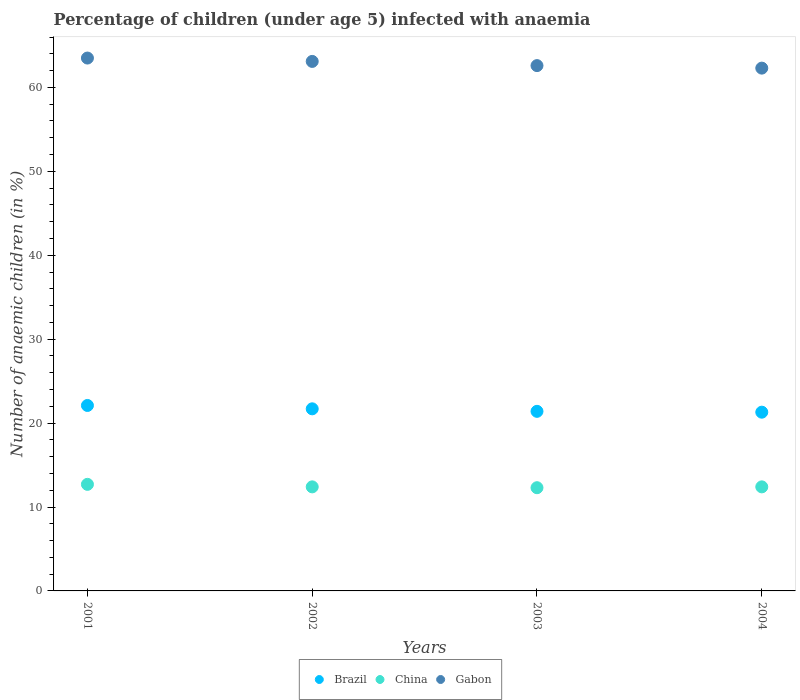How many different coloured dotlines are there?
Provide a short and direct response. 3. Is the number of dotlines equal to the number of legend labels?
Give a very brief answer. Yes. Across all years, what is the maximum percentage of children infected with anaemia in in Gabon?
Offer a terse response. 63.5. Across all years, what is the minimum percentage of children infected with anaemia in in Brazil?
Your answer should be very brief. 21.3. In which year was the percentage of children infected with anaemia in in China maximum?
Ensure brevity in your answer.  2001. In which year was the percentage of children infected with anaemia in in Brazil minimum?
Provide a short and direct response. 2004. What is the total percentage of children infected with anaemia in in Brazil in the graph?
Your answer should be very brief. 86.5. What is the difference between the percentage of children infected with anaemia in in Gabon in 2001 and that in 2004?
Ensure brevity in your answer.  1.2. What is the difference between the percentage of children infected with anaemia in in Brazil in 2004 and the percentage of children infected with anaemia in in China in 2001?
Give a very brief answer. 8.6. What is the average percentage of children infected with anaemia in in China per year?
Your answer should be compact. 12.45. In the year 2004, what is the difference between the percentage of children infected with anaemia in in China and percentage of children infected with anaemia in in Brazil?
Your answer should be very brief. -8.9. In how many years, is the percentage of children infected with anaemia in in China greater than 2 %?
Make the answer very short. 4. What is the ratio of the percentage of children infected with anaemia in in Gabon in 2001 to that in 2002?
Your answer should be compact. 1.01. Is the percentage of children infected with anaemia in in Gabon in 2002 less than that in 2004?
Ensure brevity in your answer.  No. Is the difference between the percentage of children infected with anaemia in in China in 2001 and 2002 greater than the difference between the percentage of children infected with anaemia in in Brazil in 2001 and 2002?
Your answer should be very brief. No. What is the difference between the highest and the second highest percentage of children infected with anaemia in in Gabon?
Ensure brevity in your answer.  0.4. What is the difference between the highest and the lowest percentage of children infected with anaemia in in Gabon?
Offer a terse response. 1.2. In how many years, is the percentage of children infected with anaemia in in China greater than the average percentage of children infected with anaemia in in China taken over all years?
Ensure brevity in your answer.  1. How many dotlines are there?
Make the answer very short. 3. How many legend labels are there?
Provide a short and direct response. 3. What is the title of the graph?
Ensure brevity in your answer.  Percentage of children (under age 5) infected with anaemia. Does "Dominica" appear as one of the legend labels in the graph?
Your answer should be very brief. No. What is the label or title of the X-axis?
Make the answer very short. Years. What is the label or title of the Y-axis?
Ensure brevity in your answer.  Number of anaemic children (in %). What is the Number of anaemic children (in %) of Brazil in 2001?
Ensure brevity in your answer.  22.1. What is the Number of anaemic children (in %) of Gabon in 2001?
Offer a very short reply. 63.5. What is the Number of anaemic children (in %) in Brazil in 2002?
Your response must be concise. 21.7. What is the Number of anaemic children (in %) in Gabon in 2002?
Your response must be concise. 63.1. What is the Number of anaemic children (in %) of Brazil in 2003?
Offer a very short reply. 21.4. What is the Number of anaemic children (in %) of Gabon in 2003?
Your response must be concise. 62.6. What is the Number of anaemic children (in %) of Brazil in 2004?
Your answer should be compact. 21.3. What is the Number of anaemic children (in %) of Gabon in 2004?
Offer a very short reply. 62.3. Across all years, what is the maximum Number of anaemic children (in %) in Brazil?
Give a very brief answer. 22.1. Across all years, what is the maximum Number of anaemic children (in %) of China?
Provide a short and direct response. 12.7. Across all years, what is the maximum Number of anaemic children (in %) in Gabon?
Offer a terse response. 63.5. Across all years, what is the minimum Number of anaemic children (in %) in Brazil?
Ensure brevity in your answer.  21.3. Across all years, what is the minimum Number of anaemic children (in %) in Gabon?
Keep it short and to the point. 62.3. What is the total Number of anaemic children (in %) of Brazil in the graph?
Make the answer very short. 86.5. What is the total Number of anaemic children (in %) in China in the graph?
Provide a succinct answer. 49.8. What is the total Number of anaemic children (in %) of Gabon in the graph?
Your answer should be very brief. 251.5. What is the difference between the Number of anaemic children (in %) of Brazil in 2001 and that in 2002?
Keep it short and to the point. 0.4. What is the difference between the Number of anaemic children (in %) in China in 2001 and that in 2002?
Give a very brief answer. 0.3. What is the difference between the Number of anaemic children (in %) in Brazil in 2001 and that in 2004?
Your response must be concise. 0.8. What is the difference between the Number of anaemic children (in %) in Brazil in 2002 and that in 2003?
Provide a short and direct response. 0.3. What is the difference between the Number of anaemic children (in %) in China in 2002 and that in 2003?
Provide a short and direct response. 0.1. What is the difference between the Number of anaemic children (in %) in China in 2002 and that in 2004?
Your answer should be very brief. 0. What is the difference between the Number of anaemic children (in %) in Gabon in 2002 and that in 2004?
Your answer should be very brief. 0.8. What is the difference between the Number of anaemic children (in %) in Brazil in 2003 and that in 2004?
Give a very brief answer. 0.1. What is the difference between the Number of anaemic children (in %) in China in 2003 and that in 2004?
Provide a succinct answer. -0.1. What is the difference between the Number of anaemic children (in %) of Brazil in 2001 and the Number of anaemic children (in %) of Gabon in 2002?
Ensure brevity in your answer.  -41. What is the difference between the Number of anaemic children (in %) in China in 2001 and the Number of anaemic children (in %) in Gabon in 2002?
Your answer should be compact. -50.4. What is the difference between the Number of anaemic children (in %) in Brazil in 2001 and the Number of anaemic children (in %) in Gabon in 2003?
Give a very brief answer. -40.5. What is the difference between the Number of anaemic children (in %) of China in 2001 and the Number of anaemic children (in %) of Gabon in 2003?
Your answer should be very brief. -49.9. What is the difference between the Number of anaemic children (in %) of Brazil in 2001 and the Number of anaemic children (in %) of Gabon in 2004?
Your answer should be very brief. -40.2. What is the difference between the Number of anaemic children (in %) in China in 2001 and the Number of anaemic children (in %) in Gabon in 2004?
Offer a terse response. -49.6. What is the difference between the Number of anaemic children (in %) in Brazil in 2002 and the Number of anaemic children (in %) in China in 2003?
Provide a succinct answer. 9.4. What is the difference between the Number of anaemic children (in %) in Brazil in 2002 and the Number of anaemic children (in %) in Gabon in 2003?
Your response must be concise. -40.9. What is the difference between the Number of anaemic children (in %) of China in 2002 and the Number of anaemic children (in %) of Gabon in 2003?
Offer a terse response. -50.2. What is the difference between the Number of anaemic children (in %) of Brazil in 2002 and the Number of anaemic children (in %) of Gabon in 2004?
Ensure brevity in your answer.  -40.6. What is the difference between the Number of anaemic children (in %) of China in 2002 and the Number of anaemic children (in %) of Gabon in 2004?
Your answer should be compact. -49.9. What is the difference between the Number of anaemic children (in %) in Brazil in 2003 and the Number of anaemic children (in %) in Gabon in 2004?
Your response must be concise. -40.9. What is the difference between the Number of anaemic children (in %) in China in 2003 and the Number of anaemic children (in %) in Gabon in 2004?
Ensure brevity in your answer.  -50. What is the average Number of anaemic children (in %) in Brazil per year?
Ensure brevity in your answer.  21.62. What is the average Number of anaemic children (in %) in China per year?
Ensure brevity in your answer.  12.45. What is the average Number of anaemic children (in %) in Gabon per year?
Ensure brevity in your answer.  62.88. In the year 2001, what is the difference between the Number of anaemic children (in %) in Brazil and Number of anaemic children (in %) in Gabon?
Offer a terse response. -41.4. In the year 2001, what is the difference between the Number of anaemic children (in %) in China and Number of anaemic children (in %) in Gabon?
Provide a short and direct response. -50.8. In the year 2002, what is the difference between the Number of anaemic children (in %) of Brazil and Number of anaemic children (in %) of Gabon?
Give a very brief answer. -41.4. In the year 2002, what is the difference between the Number of anaemic children (in %) of China and Number of anaemic children (in %) of Gabon?
Make the answer very short. -50.7. In the year 2003, what is the difference between the Number of anaemic children (in %) in Brazil and Number of anaemic children (in %) in China?
Your response must be concise. 9.1. In the year 2003, what is the difference between the Number of anaemic children (in %) of Brazil and Number of anaemic children (in %) of Gabon?
Keep it short and to the point. -41.2. In the year 2003, what is the difference between the Number of anaemic children (in %) of China and Number of anaemic children (in %) of Gabon?
Provide a short and direct response. -50.3. In the year 2004, what is the difference between the Number of anaemic children (in %) of Brazil and Number of anaemic children (in %) of China?
Your answer should be compact. 8.9. In the year 2004, what is the difference between the Number of anaemic children (in %) in Brazil and Number of anaemic children (in %) in Gabon?
Offer a terse response. -41. In the year 2004, what is the difference between the Number of anaemic children (in %) of China and Number of anaemic children (in %) of Gabon?
Make the answer very short. -49.9. What is the ratio of the Number of anaemic children (in %) of Brazil in 2001 to that in 2002?
Give a very brief answer. 1.02. What is the ratio of the Number of anaemic children (in %) in China in 2001 to that in 2002?
Offer a terse response. 1.02. What is the ratio of the Number of anaemic children (in %) of Brazil in 2001 to that in 2003?
Provide a short and direct response. 1.03. What is the ratio of the Number of anaemic children (in %) in China in 2001 to that in 2003?
Offer a very short reply. 1.03. What is the ratio of the Number of anaemic children (in %) of Gabon in 2001 to that in 2003?
Make the answer very short. 1.01. What is the ratio of the Number of anaemic children (in %) of Brazil in 2001 to that in 2004?
Give a very brief answer. 1.04. What is the ratio of the Number of anaemic children (in %) in China in 2001 to that in 2004?
Your answer should be very brief. 1.02. What is the ratio of the Number of anaemic children (in %) in Gabon in 2001 to that in 2004?
Make the answer very short. 1.02. What is the ratio of the Number of anaemic children (in %) of Brazil in 2002 to that in 2003?
Give a very brief answer. 1.01. What is the ratio of the Number of anaemic children (in %) in China in 2002 to that in 2003?
Your answer should be very brief. 1.01. What is the ratio of the Number of anaemic children (in %) in Brazil in 2002 to that in 2004?
Keep it short and to the point. 1.02. What is the ratio of the Number of anaemic children (in %) in Gabon in 2002 to that in 2004?
Your response must be concise. 1.01. What is the ratio of the Number of anaemic children (in %) of Brazil in 2003 to that in 2004?
Your answer should be compact. 1. What is the difference between the highest and the second highest Number of anaemic children (in %) of China?
Give a very brief answer. 0.3. What is the difference between the highest and the second highest Number of anaemic children (in %) in Gabon?
Provide a short and direct response. 0.4. What is the difference between the highest and the lowest Number of anaemic children (in %) of Brazil?
Ensure brevity in your answer.  0.8. 